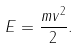Convert formula to latex. <formula><loc_0><loc_0><loc_500><loc_500>E = \frac { m v ^ { 2 } } { 2 } .</formula> 